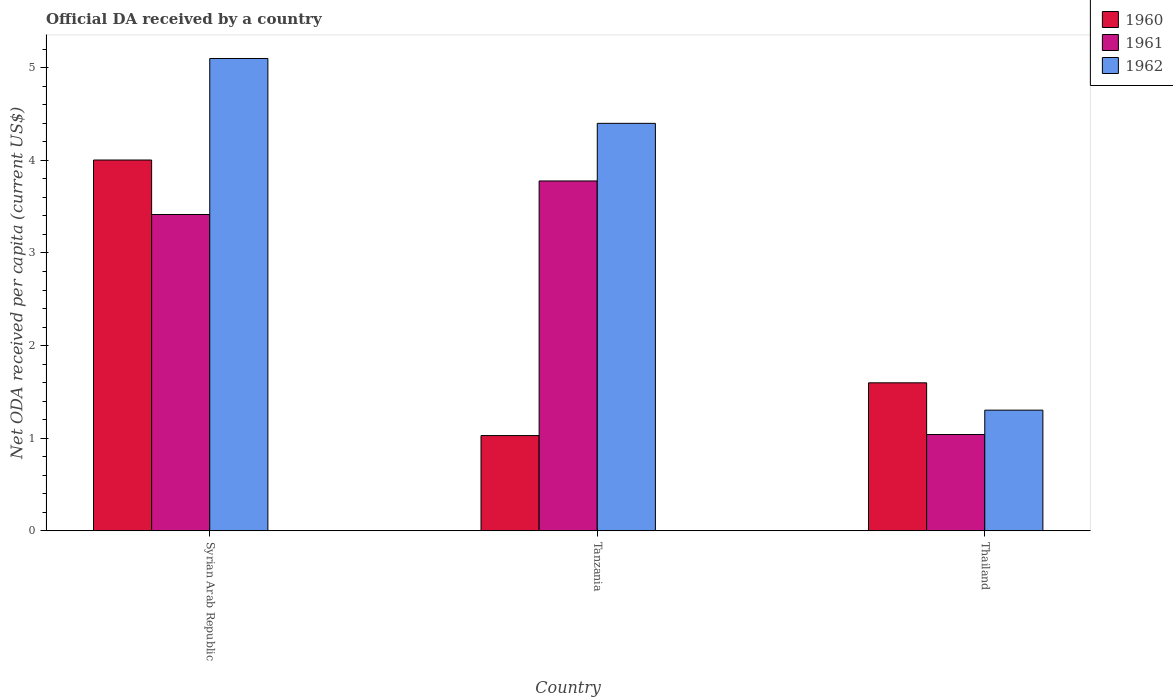Are the number of bars on each tick of the X-axis equal?
Offer a very short reply. Yes. How many bars are there on the 2nd tick from the right?
Your response must be concise. 3. What is the label of the 1st group of bars from the left?
Give a very brief answer. Syrian Arab Republic. What is the ODA received in in 1960 in Tanzania?
Your answer should be very brief. 1.03. Across all countries, what is the maximum ODA received in in 1962?
Provide a succinct answer. 5.1. Across all countries, what is the minimum ODA received in in 1960?
Your answer should be very brief. 1.03. In which country was the ODA received in in 1962 maximum?
Ensure brevity in your answer.  Syrian Arab Republic. In which country was the ODA received in in 1961 minimum?
Provide a short and direct response. Thailand. What is the total ODA received in in 1961 in the graph?
Give a very brief answer. 8.23. What is the difference between the ODA received in in 1960 in Syrian Arab Republic and that in Thailand?
Provide a short and direct response. 2.41. What is the difference between the ODA received in in 1960 in Thailand and the ODA received in in 1961 in Tanzania?
Your answer should be very brief. -2.18. What is the average ODA received in in 1961 per country?
Provide a short and direct response. 2.74. What is the difference between the ODA received in of/in 1961 and ODA received in of/in 1962 in Syrian Arab Republic?
Your response must be concise. -1.68. In how many countries, is the ODA received in in 1960 greater than 5 US$?
Your response must be concise. 0. What is the ratio of the ODA received in in 1961 in Syrian Arab Republic to that in Thailand?
Ensure brevity in your answer.  3.29. Is the ODA received in in 1962 in Syrian Arab Republic less than that in Tanzania?
Make the answer very short. No. What is the difference between the highest and the second highest ODA received in in 1960?
Provide a short and direct response. -2.41. What is the difference between the highest and the lowest ODA received in in 1960?
Your response must be concise. 2.98. What does the 1st bar from the right in Syrian Arab Republic represents?
Give a very brief answer. 1962. Is it the case that in every country, the sum of the ODA received in in 1962 and ODA received in in 1960 is greater than the ODA received in in 1961?
Provide a succinct answer. Yes. How many bars are there?
Give a very brief answer. 9. How many countries are there in the graph?
Keep it short and to the point. 3. What is the difference between two consecutive major ticks on the Y-axis?
Make the answer very short. 1. Are the values on the major ticks of Y-axis written in scientific E-notation?
Give a very brief answer. No. Where does the legend appear in the graph?
Offer a terse response. Top right. What is the title of the graph?
Keep it short and to the point. Official DA received by a country. Does "1986" appear as one of the legend labels in the graph?
Your answer should be compact. No. What is the label or title of the X-axis?
Offer a terse response. Country. What is the label or title of the Y-axis?
Provide a short and direct response. Net ODA received per capita (current US$). What is the Net ODA received per capita (current US$) in 1960 in Syrian Arab Republic?
Give a very brief answer. 4. What is the Net ODA received per capita (current US$) in 1961 in Syrian Arab Republic?
Ensure brevity in your answer.  3.42. What is the Net ODA received per capita (current US$) of 1962 in Syrian Arab Republic?
Ensure brevity in your answer.  5.1. What is the Net ODA received per capita (current US$) of 1960 in Tanzania?
Give a very brief answer. 1.03. What is the Net ODA received per capita (current US$) in 1961 in Tanzania?
Provide a short and direct response. 3.78. What is the Net ODA received per capita (current US$) of 1962 in Tanzania?
Offer a very short reply. 4.4. What is the Net ODA received per capita (current US$) of 1960 in Thailand?
Provide a succinct answer. 1.6. What is the Net ODA received per capita (current US$) of 1961 in Thailand?
Offer a terse response. 1.04. What is the Net ODA received per capita (current US$) of 1962 in Thailand?
Provide a succinct answer. 1.3. Across all countries, what is the maximum Net ODA received per capita (current US$) of 1960?
Keep it short and to the point. 4. Across all countries, what is the maximum Net ODA received per capita (current US$) in 1961?
Make the answer very short. 3.78. Across all countries, what is the maximum Net ODA received per capita (current US$) in 1962?
Provide a short and direct response. 5.1. Across all countries, what is the minimum Net ODA received per capita (current US$) in 1960?
Ensure brevity in your answer.  1.03. Across all countries, what is the minimum Net ODA received per capita (current US$) in 1961?
Provide a succinct answer. 1.04. Across all countries, what is the minimum Net ODA received per capita (current US$) in 1962?
Make the answer very short. 1.3. What is the total Net ODA received per capita (current US$) of 1960 in the graph?
Your response must be concise. 6.63. What is the total Net ODA received per capita (current US$) in 1961 in the graph?
Offer a terse response. 8.23. What is the total Net ODA received per capita (current US$) of 1962 in the graph?
Offer a terse response. 10.8. What is the difference between the Net ODA received per capita (current US$) in 1960 in Syrian Arab Republic and that in Tanzania?
Offer a terse response. 2.98. What is the difference between the Net ODA received per capita (current US$) in 1961 in Syrian Arab Republic and that in Tanzania?
Your answer should be very brief. -0.36. What is the difference between the Net ODA received per capita (current US$) in 1962 in Syrian Arab Republic and that in Tanzania?
Provide a succinct answer. 0.7. What is the difference between the Net ODA received per capita (current US$) of 1960 in Syrian Arab Republic and that in Thailand?
Your answer should be very brief. 2.41. What is the difference between the Net ODA received per capita (current US$) in 1961 in Syrian Arab Republic and that in Thailand?
Ensure brevity in your answer.  2.38. What is the difference between the Net ODA received per capita (current US$) in 1962 in Syrian Arab Republic and that in Thailand?
Give a very brief answer. 3.8. What is the difference between the Net ODA received per capita (current US$) of 1960 in Tanzania and that in Thailand?
Offer a very short reply. -0.57. What is the difference between the Net ODA received per capita (current US$) of 1961 in Tanzania and that in Thailand?
Your answer should be very brief. 2.74. What is the difference between the Net ODA received per capita (current US$) of 1962 in Tanzania and that in Thailand?
Offer a very short reply. 3.1. What is the difference between the Net ODA received per capita (current US$) in 1960 in Syrian Arab Republic and the Net ODA received per capita (current US$) in 1961 in Tanzania?
Make the answer very short. 0.23. What is the difference between the Net ODA received per capita (current US$) in 1960 in Syrian Arab Republic and the Net ODA received per capita (current US$) in 1962 in Tanzania?
Your answer should be very brief. -0.4. What is the difference between the Net ODA received per capita (current US$) in 1961 in Syrian Arab Republic and the Net ODA received per capita (current US$) in 1962 in Tanzania?
Your answer should be compact. -0.98. What is the difference between the Net ODA received per capita (current US$) in 1960 in Syrian Arab Republic and the Net ODA received per capita (current US$) in 1961 in Thailand?
Ensure brevity in your answer.  2.96. What is the difference between the Net ODA received per capita (current US$) of 1960 in Syrian Arab Republic and the Net ODA received per capita (current US$) of 1962 in Thailand?
Make the answer very short. 2.7. What is the difference between the Net ODA received per capita (current US$) in 1961 in Syrian Arab Republic and the Net ODA received per capita (current US$) in 1962 in Thailand?
Provide a short and direct response. 2.11. What is the difference between the Net ODA received per capita (current US$) in 1960 in Tanzania and the Net ODA received per capita (current US$) in 1961 in Thailand?
Give a very brief answer. -0.01. What is the difference between the Net ODA received per capita (current US$) in 1960 in Tanzania and the Net ODA received per capita (current US$) in 1962 in Thailand?
Give a very brief answer. -0.27. What is the difference between the Net ODA received per capita (current US$) in 1961 in Tanzania and the Net ODA received per capita (current US$) in 1962 in Thailand?
Give a very brief answer. 2.48. What is the average Net ODA received per capita (current US$) in 1960 per country?
Give a very brief answer. 2.21. What is the average Net ODA received per capita (current US$) in 1961 per country?
Ensure brevity in your answer.  2.74. What is the average Net ODA received per capita (current US$) of 1962 per country?
Keep it short and to the point. 3.6. What is the difference between the Net ODA received per capita (current US$) in 1960 and Net ODA received per capita (current US$) in 1961 in Syrian Arab Republic?
Your response must be concise. 0.59. What is the difference between the Net ODA received per capita (current US$) of 1960 and Net ODA received per capita (current US$) of 1962 in Syrian Arab Republic?
Provide a succinct answer. -1.1. What is the difference between the Net ODA received per capita (current US$) of 1961 and Net ODA received per capita (current US$) of 1962 in Syrian Arab Republic?
Offer a terse response. -1.68. What is the difference between the Net ODA received per capita (current US$) in 1960 and Net ODA received per capita (current US$) in 1961 in Tanzania?
Offer a very short reply. -2.75. What is the difference between the Net ODA received per capita (current US$) in 1960 and Net ODA received per capita (current US$) in 1962 in Tanzania?
Your answer should be very brief. -3.37. What is the difference between the Net ODA received per capita (current US$) of 1961 and Net ODA received per capita (current US$) of 1962 in Tanzania?
Your answer should be very brief. -0.62. What is the difference between the Net ODA received per capita (current US$) of 1960 and Net ODA received per capita (current US$) of 1961 in Thailand?
Provide a succinct answer. 0.56. What is the difference between the Net ODA received per capita (current US$) of 1960 and Net ODA received per capita (current US$) of 1962 in Thailand?
Your response must be concise. 0.3. What is the difference between the Net ODA received per capita (current US$) of 1961 and Net ODA received per capita (current US$) of 1962 in Thailand?
Offer a very short reply. -0.26. What is the ratio of the Net ODA received per capita (current US$) in 1960 in Syrian Arab Republic to that in Tanzania?
Make the answer very short. 3.89. What is the ratio of the Net ODA received per capita (current US$) in 1961 in Syrian Arab Republic to that in Tanzania?
Ensure brevity in your answer.  0.9. What is the ratio of the Net ODA received per capita (current US$) of 1962 in Syrian Arab Republic to that in Tanzania?
Give a very brief answer. 1.16. What is the ratio of the Net ODA received per capita (current US$) in 1960 in Syrian Arab Republic to that in Thailand?
Provide a succinct answer. 2.51. What is the ratio of the Net ODA received per capita (current US$) of 1961 in Syrian Arab Republic to that in Thailand?
Your answer should be very brief. 3.29. What is the ratio of the Net ODA received per capita (current US$) of 1962 in Syrian Arab Republic to that in Thailand?
Your response must be concise. 3.91. What is the ratio of the Net ODA received per capita (current US$) in 1960 in Tanzania to that in Thailand?
Your answer should be compact. 0.64. What is the ratio of the Net ODA received per capita (current US$) in 1961 in Tanzania to that in Thailand?
Provide a succinct answer. 3.63. What is the ratio of the Net ODA received per capita (current US$) in 1962 in Tanzania to that in Thailand?
Offer a terse response. 3.38. What is the difference between the highest and the second highest Net ODA received per capita (current US$) in 1960?
Provide a short and direct response. 2.41. What is the difference between the highest and the second highest Net ODA received per capita (current US$) of 1961?
Provide a short and direct response. 0.36. What is the difference between the highest and the second highest Net ODA received per capita (current US$) in 1962?
Offer a very short reply. 0.7. What is the difference between the highest and the lowest Net ODA received per capita (current US$) of 1960?
Provide a succinct answer. 2.98. What is the difference between the highest and the lowest Net ODA received per capita (current US$) in 1961?
Offer a very short reply. 2.74. What is the difference between the highest and the lowest Net ODA received per capita (current US$) in 1962?
Ensure brevity in your answer.  3.8. 